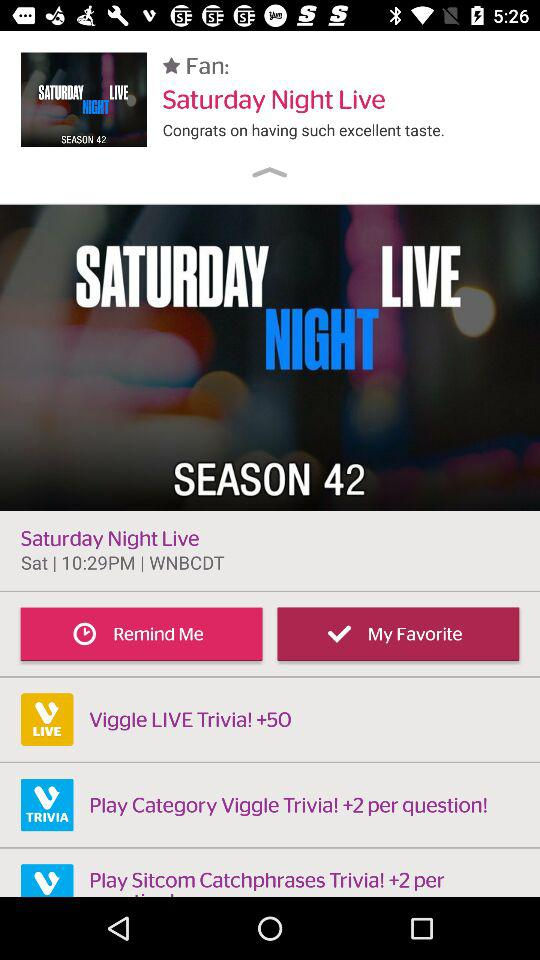What is the time of the show? The time of the show is 10:29 p.m. 